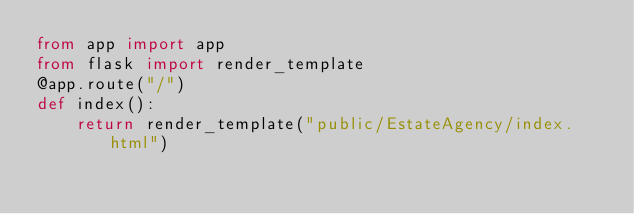Convert code to text. <code><loc_0><loc_0><loc_500><loc_500><_Python_>from app import app
from flask import render_template
@app.route("/")
def index():
    return render_template("public/EstateAgency/index.html")

</code> 